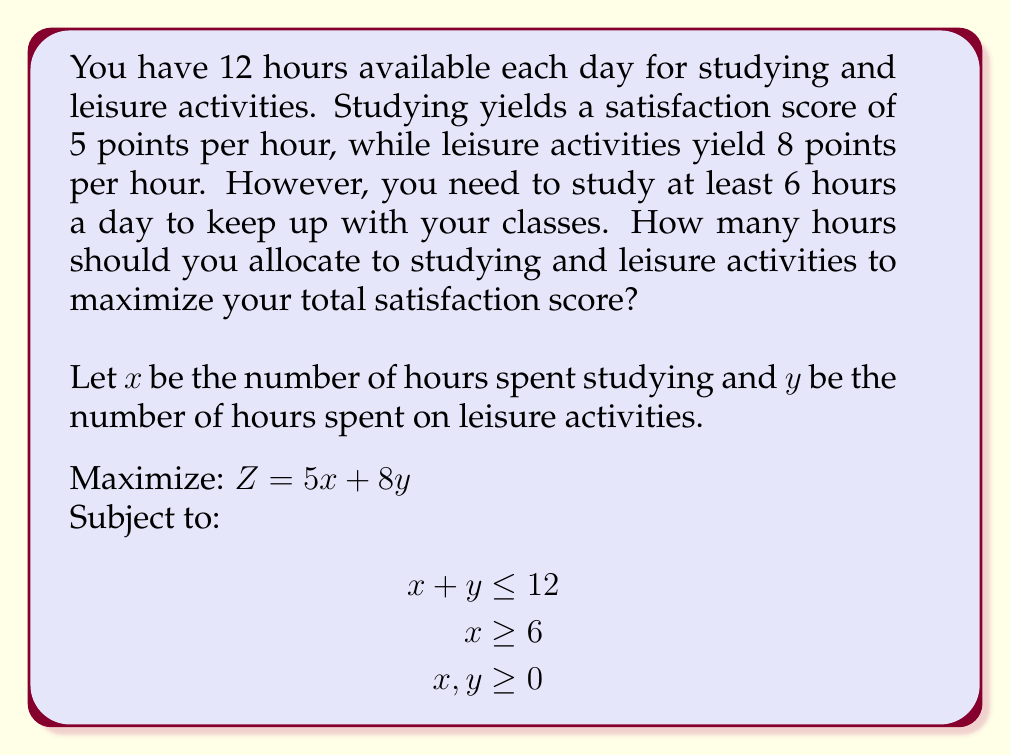Could you help me with this problem? To solve this optimization problem, we'll use the following steps:

1) First, let's graph the constraints:
   
   [asy]
   import graph;
   size(200);
   xaxis("x (Study hours)", 0, 13, Arrow);
   yaxis("y (Leisure hours)", 0, 13, Arrow);
   draw((0,12)--(12,0), blue);
   draw((6,0)--(6,6), red);
   label("x + y = 12", (6,7), E);
   label("x = 6", (6.5,3), E);
   fill((6,0)--(6,6)--(12,0)--cycle, lightgreen);
   [/asy]

2) The feasible region is the green triangle. The optimal solution will be at one of the corner points of this region.

3) The corner points are:
   (6, 6), (6, 0), and (12, 0)

4) Let's evaluate the objective function $Z = 5x + 8y$ at each point:
   
   At (6, 6): $Z = 5(6) + 8(6) = 30 + 48 = 78$
   At (6, 0): $Z = 5(6) + 8(0) = 30 + 0 = 30$
   At (12, 0): $Z = 5(12) + 8(0) = 60 + 0 = 60$

5) The maximum value occurs at the point (6, 6), which means 6 hours of studying and 6 hours of leisure activities.

This solution makes sense intuitively: you study the minimum required amount (6 hours) to keep up with classes, and then spend the rest of your time on leisure activities which yield more satisfaction points per hour.
Answer: The optimal allocation is 6 hours for studying and 6 hours for leisure activities, yielding a maximum satisfaction score of 78 points. 